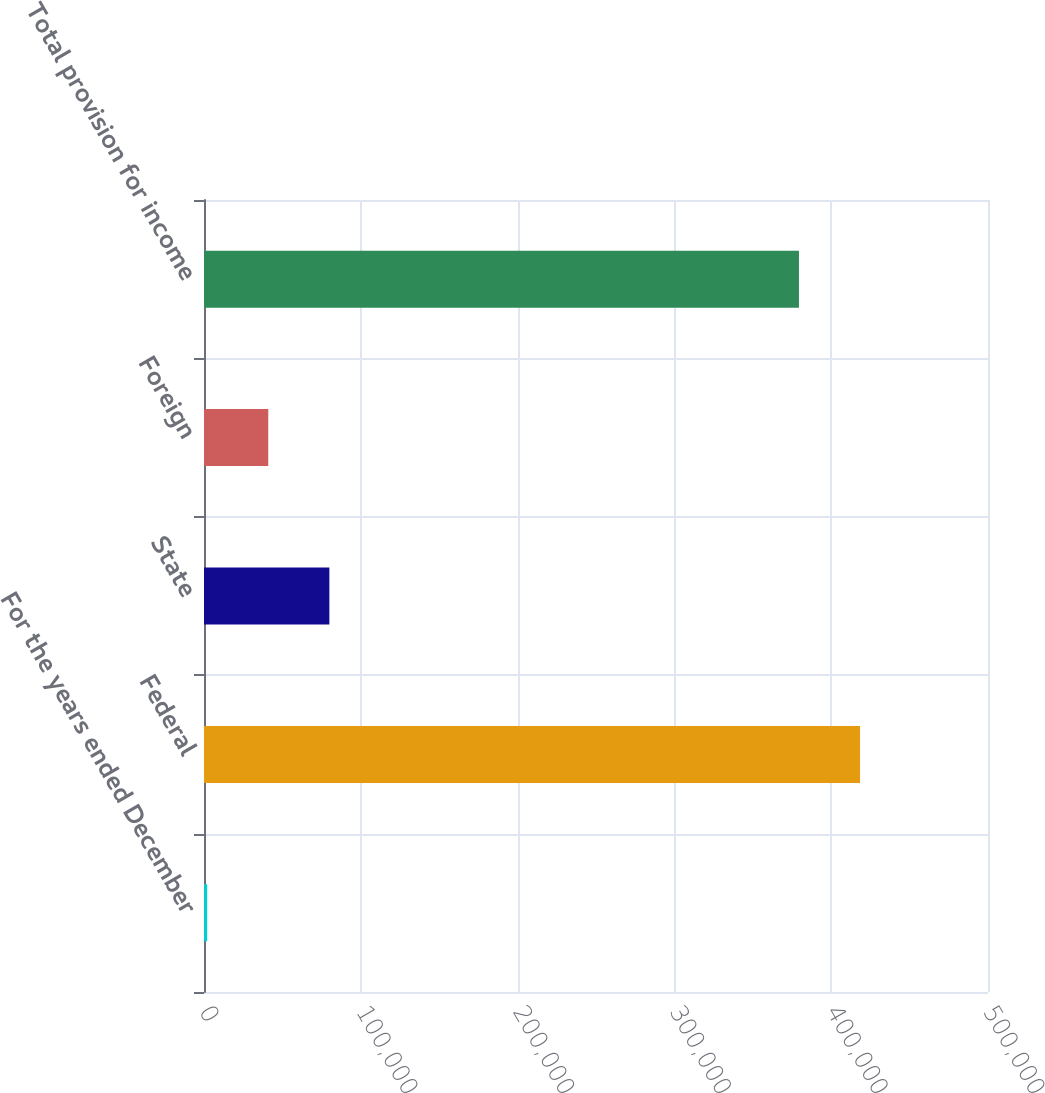Convert chart to OTSL. <chart><loc_0><loc_0><loc_500><loc_500><bar_chart><fcel>For the years ended December<fcel>Federal<fcel>State<fcel>Foreign<fcel>Total provision for income<nl><fcel>2016<fcel>418406<fcel>79953.8<fcel>40984.9<fcel>379437<nl></chart> 